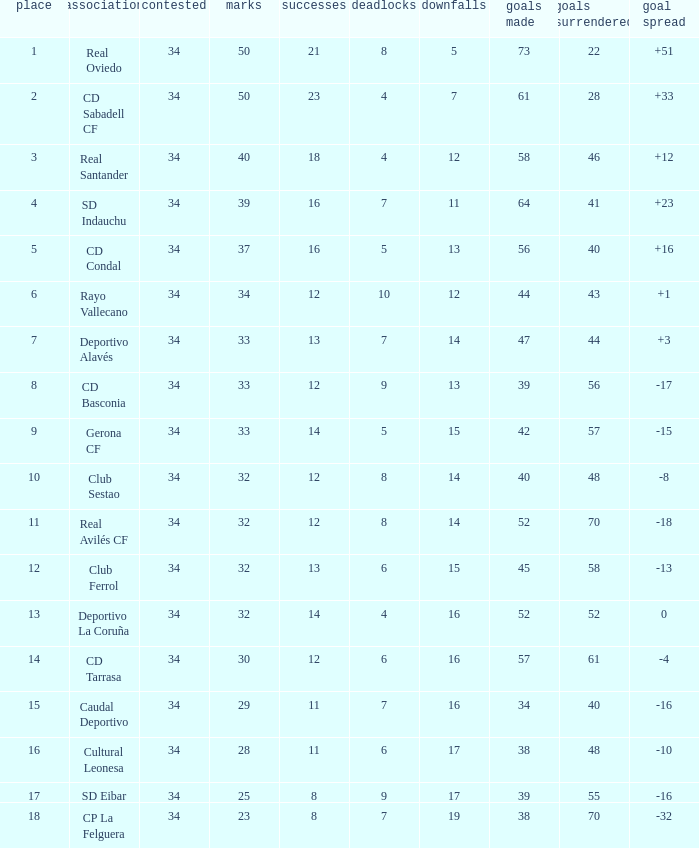Which Wins have a Goal Difference larger than 0, and Goals against larger than 40, and a Position smaller than 6, and a Club of sd indauchu? 16.0. 